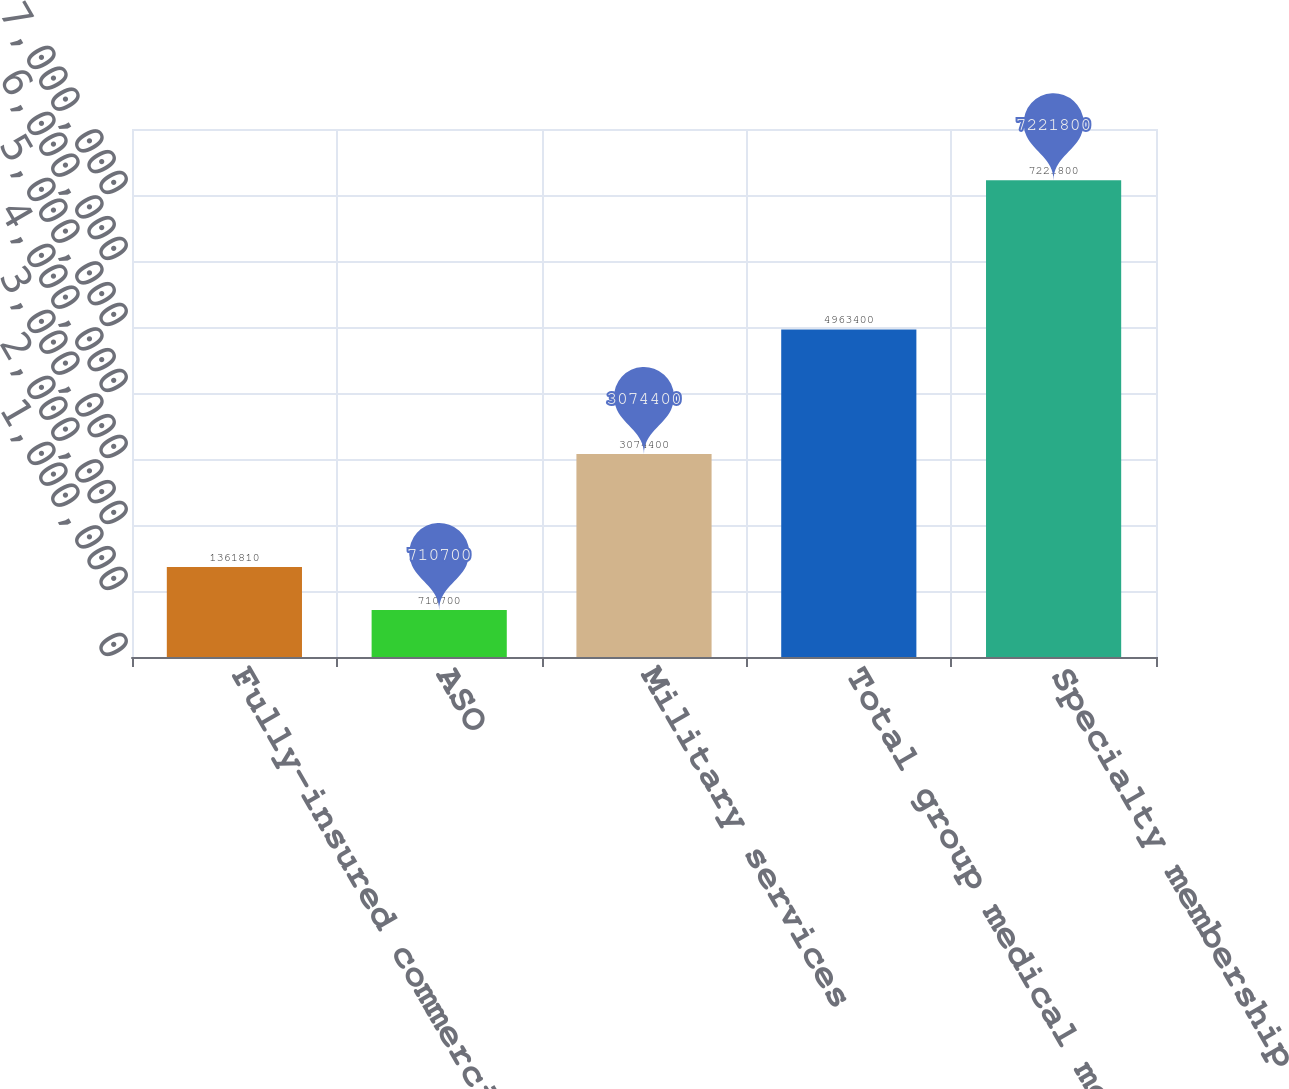Convert chart to OTSL. <chart><loc_0><loc_0><loc_500><loc_500><bar_chart><fcel>Fully-insured commercial group<fcel>ASO<fcel>Military services<fcel>Total group medical members<fcel>Specialty membership (a)<nl><fcel>1.36181e+06<fcel>710700<fcel>3.0744e+06<fcel>4.9634e+06<fcel>7.2218e+06<nl></chart> 